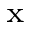<formula> <loc_0><loc_0><loc_500><loc_500>_ { x }</formula> 